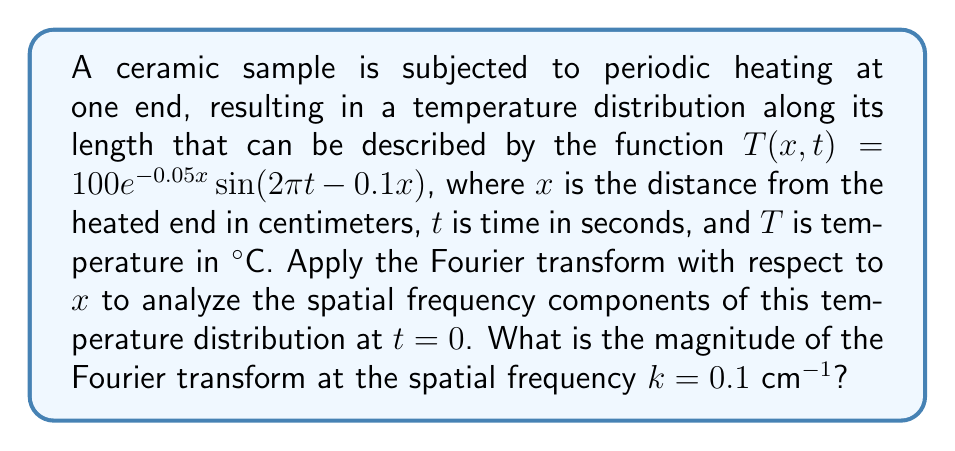Help me with this question. To solve this problem, we'll follow these steps:

1) First, we need to consider the temperature distribution at $t=0$:
   $T(x,0) = 100e^{-0.05x}\sin(-0.1x)$

2) The Fourier transform of $T(x,0)$ with respect to $x$ is given by:
   $$F(k) = \int_{-\infty}^{\infty} T(x,0) e^{-ikx} dx$$

3) Substituting our function:
   $$F(k) = 100\int_{0}^{\infty} e^{-0.05x}\sin(-0.1x) e^{-ikx} dx$$
   Note that we changed the lower limit to 0 as the function is only defined for positive $x$.

4) This integral can be solved using complex analysis, but for simplicity, we can use the known Fourier transform pair:
   $$\frac{a\sin(bx)}{x^2 + a^2} \leftrightarrow \frac{\pi}{2}e^{-a|k|}[\text{sgn}(k-b) - \text{sgn}(k+b)]$$

5) In our case, $a=0.05$ and $b=0.1$. The Fourier transform becomes:
   $$F(k) = 1000\pi\left[\frac{e^{-0.05|k-0.1|}}{(k-0.1)^2 + 0.05^2} - \frac{e^{-0.05|k+0.1|}}{(k+0.1)^2 + 0.05^2}\right]$$

6) To find the magnitude at $k=0.1$, we substitute this value:
   $$|F(0.1)| = 1000\pi\left|\frac{1}{0.05^2} - \frac{e^{-0.01}}{0.2^2 + 0.05^2}\right|$$

7) Calculating this:
   $$|F(0.1)| = 1000\pi\left|\frac{400}{1} - \frac{0.99}{0.0425}\right| \approx 1,233,185 \text{ cm}°\text{C}$$
Answer: The magnitude of the Fourier transform at the spatial frequency $k=0.1$ cm$^{-1}$ is approximately 1,233,185 cm°C. 